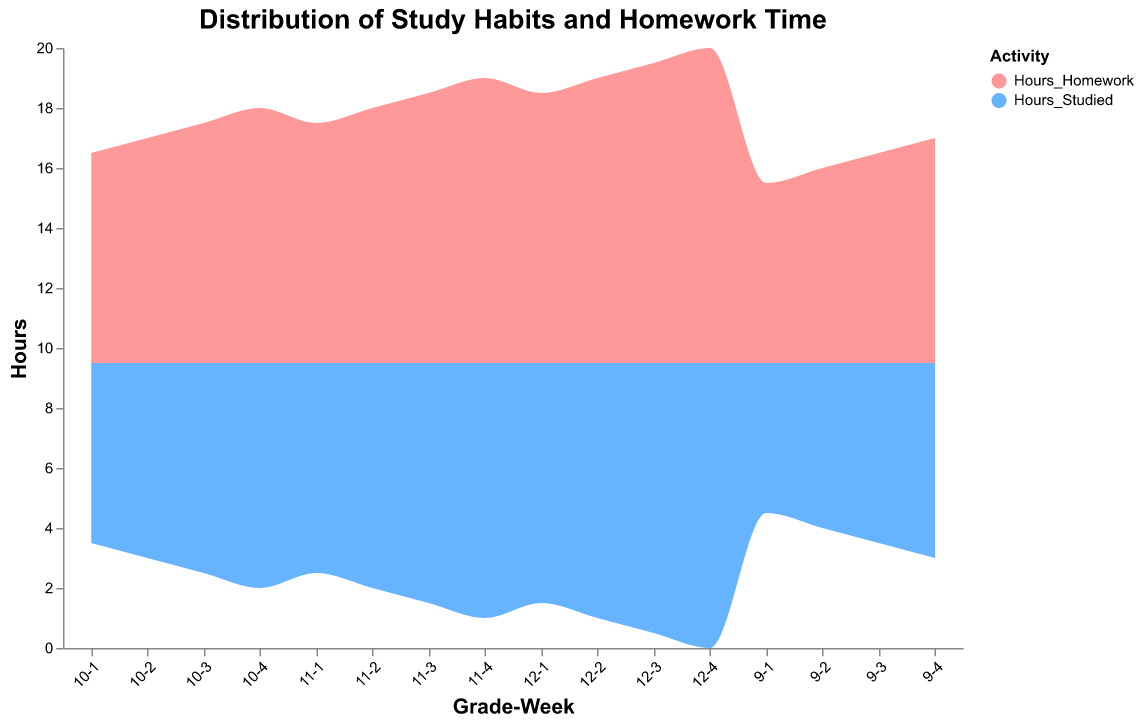What's the title of the figure? The title is given at the top of the figure.
Answer: Distribution of Study Habits and Homework Time How many different grades are represented in this figure? Each grade is marked clearly in the data with GradeWeek labels on the x-axis.
Answer: 4 How do the hours studied change from week 1 to week 4 for grade 10? Observe the "Hours_Studied" for Grade 10 across the 4 weeks. They increase from 6 to 7.5 hours.
Answer: They increase from 6 to 7.5 hours What are the colors representing "Hours Studied" and "Hours Homework"? The legend explains the color representation of each activity.
Answer: Pink (#ff9999) for Hours Studied and Blue (#66b3ff) for Hours Homework Is the amount of "Hours Homework" consistently higher, lower, or equal to "Hours Studied" for grade 11? Compare the values of "Hours Homework" and "Hours Studied" within grade 11. For every week, "Hours Homework" is higher than "Hours Studied".
Answer: Higher What is the total trend of both activities from grade 9 to grade 12? Adding up "Hours Studied" and "Hours Homework" per week per grade, the overall trend shows an incremental increase.
Answer: Increasing trend Which week shows the maximum total study hours across all grades? Sum up "Hours_Studied" and "Hours_Homework" for each week across all grades and compare. The 4th week has the maximum total across all grades.
Answer: Week 4 For Grade 12, what is the difference between the hours studied and homework hours in week 3? The hours studied for Grade 12 week 3 is 9 and the homework hours is 10. The difference is 10 - 9 = 1.
Answer: 1 hour Compare the difference in hours spent on homework between grade 9 and grade 12 in week 2. Grade 9 has 6.5 hours in week 2 and Grade 12 has 9.5 hours. The difference is 9.5 - 6.5 = 3.
Answer: Grade 12 spends 3 more hours Is there any grade where the growth in study habit hours is consistent over all 4 weeks? Grade 9 shows consistent increase from 5 to 6.5. Similarly, Grade 12 shows consistent increase from 8 to 9.5.
Answer: Yes, Grade 9 and Grade 12 